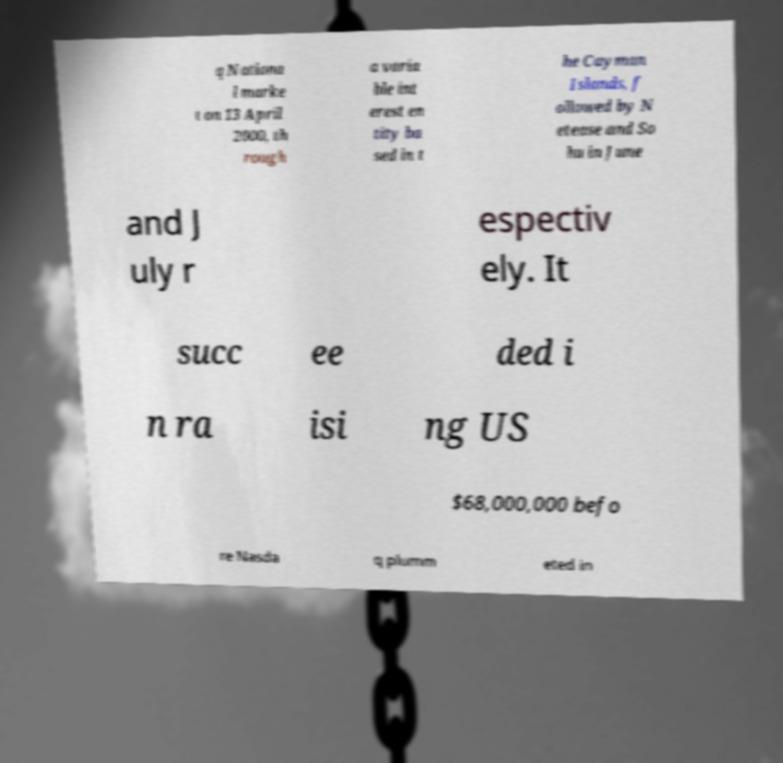For documentation purposes, I need the text within this image transcribed. Could you provide that? q Nationa l marke t on 13 April 2000, th rough a varia ble int erest en tity ba sed in t he Cayman Islands, f ollowed by N etease and So hu in June and J uly r espectiv ely. It succ ee ded i n ra isi ng US $68,000,000 befo re Nasda q plumm eted in 